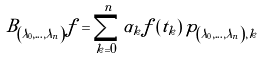Convert formula to latex. <formula><loc_0><loc_0><loc_500><loc_500>B _ { \left ( \lambda _ { 0 } , \dots , \lambda _ { n } \right ) } f = \sum _ { k = 0 } ^ { n } \alpha _ { k } f \left ( t _ { k } \right ) p _ { \left ( \lambda _ { 0 } , \dots , \lambda _ { n } \right ) , k }</formula> 